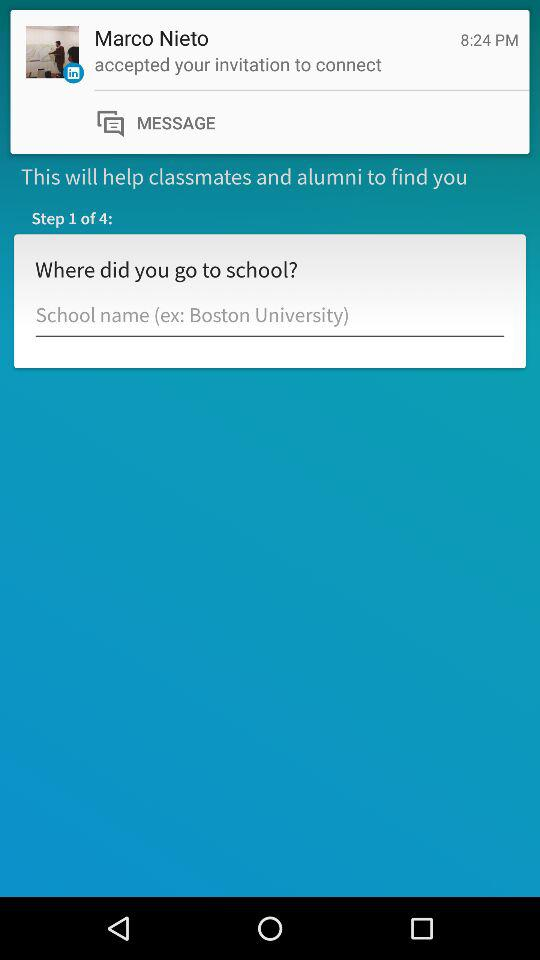At what time was your invitation accepted? Your invitation was accepted at 8:24 PM. 